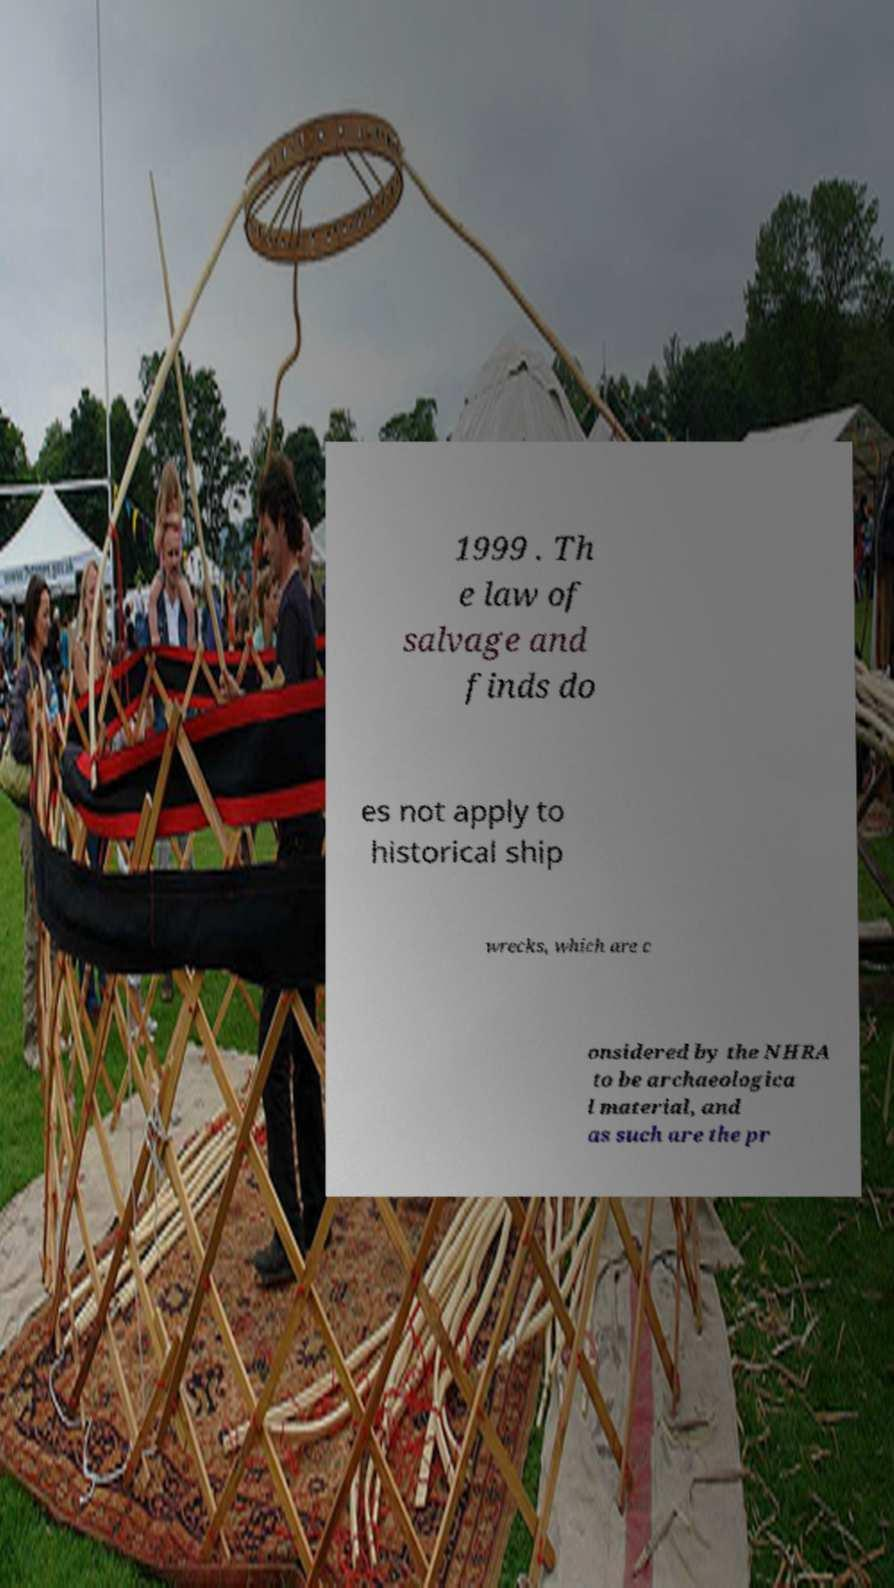Can you accurately transcribe the text from the provided image for me? 1999 . Th e law of salvage and finds do es not apply to historical ship wrecks, which are c onsidered by the NHRA to be archaeologica l material, and as such are the pr 